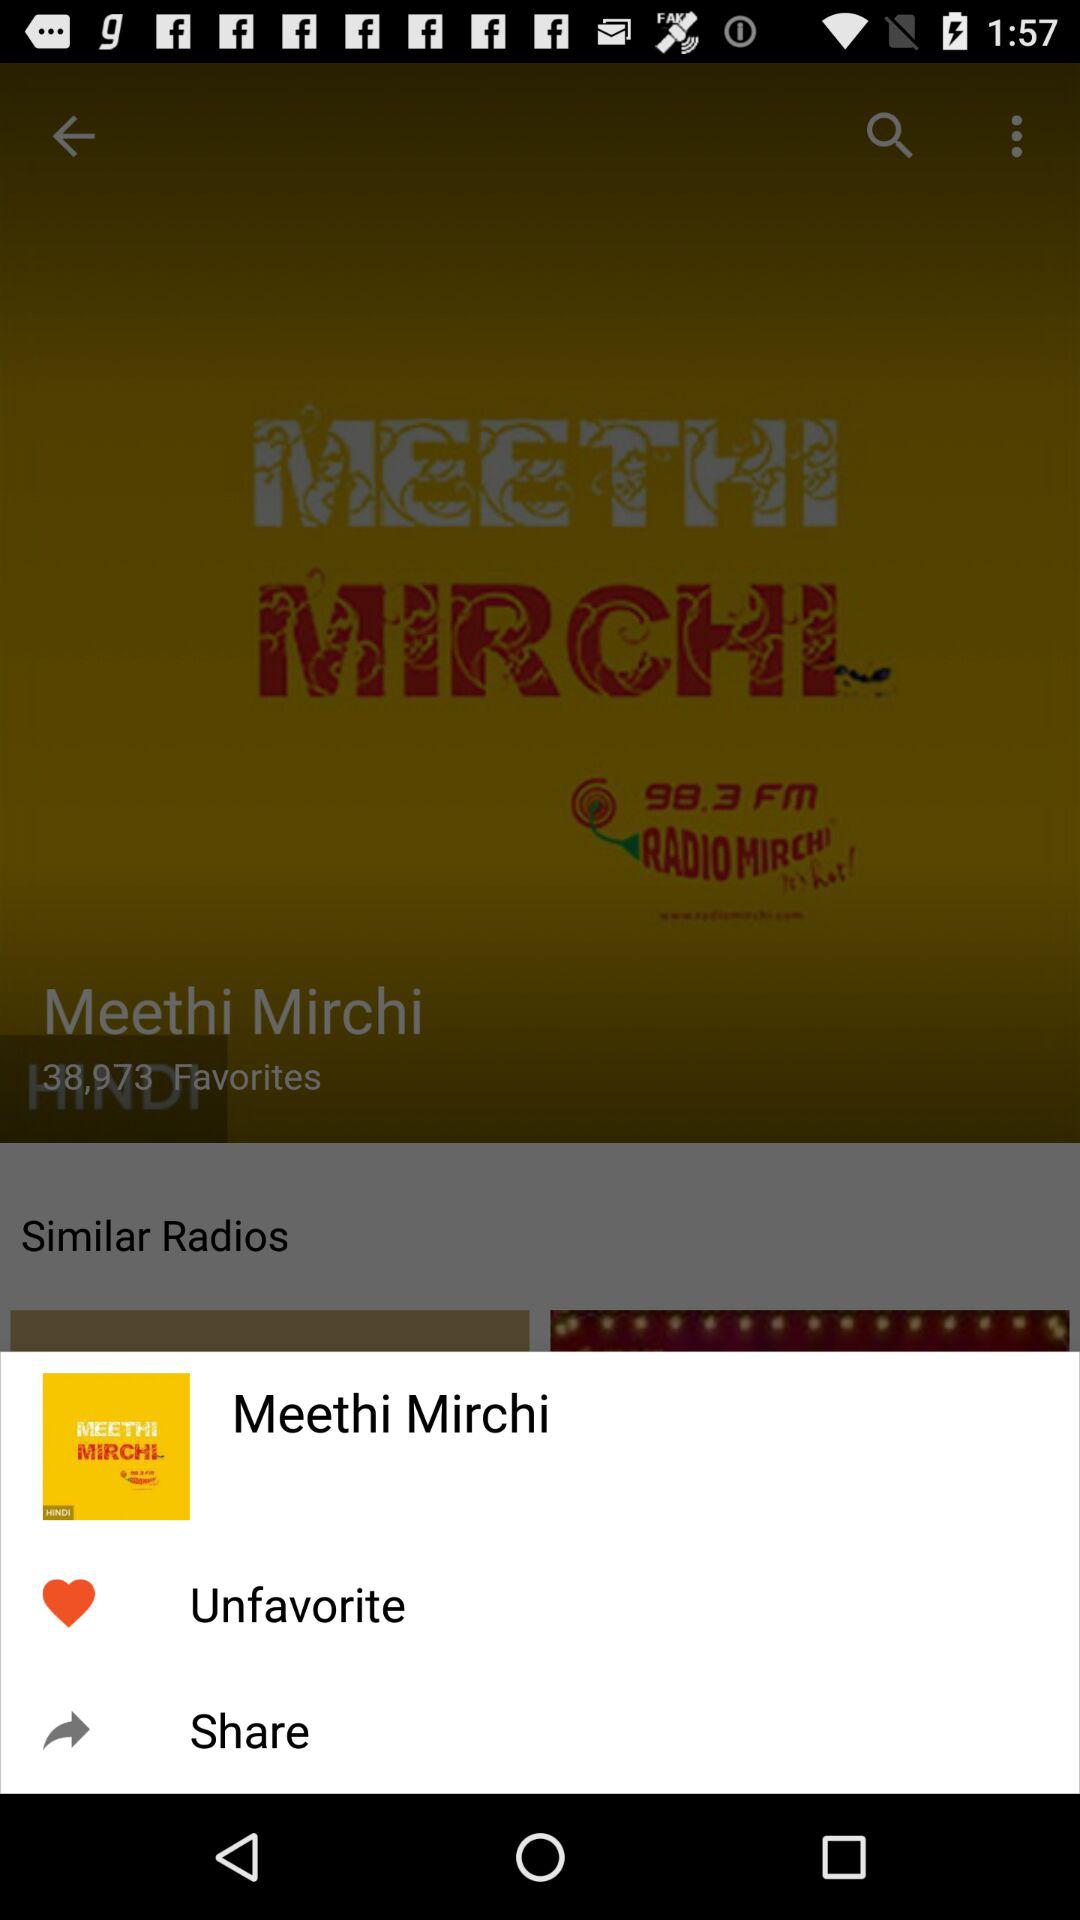What is the radio channel frequency? The radio channel frequency is 98.3. 